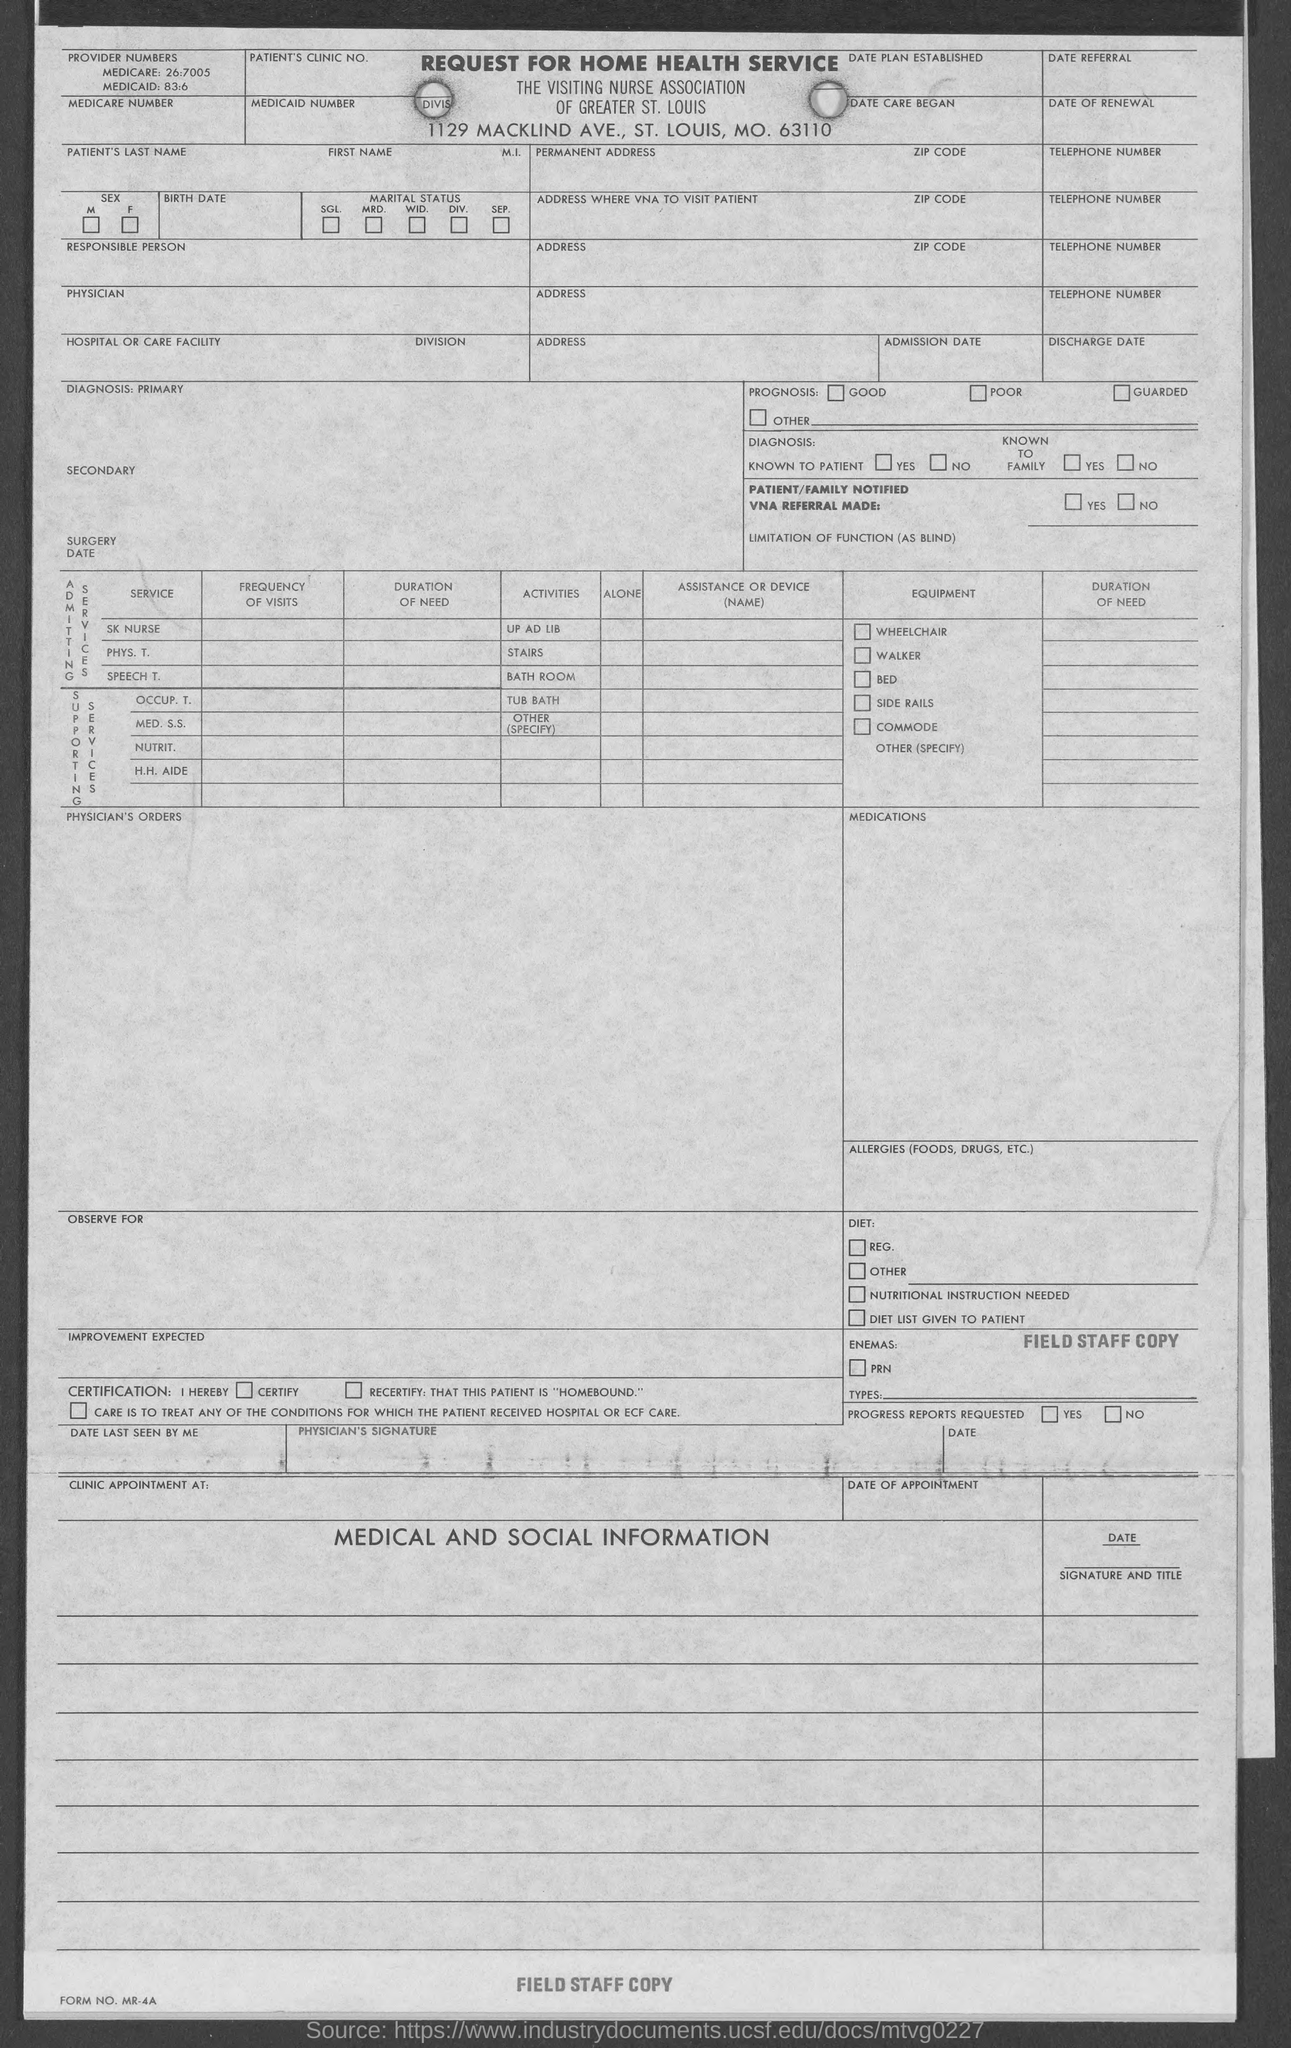What is the medicare number provided in the given form ?
Provide a short and direct response. 26:7005. What is the medicaid number mentioned in the given form ?
Provide a succinct answer. 83:6. What is the name of the service mentioned in the given form ?
Your answer should be compact. Request for home health service. 